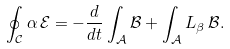Convert formula to latex. <formula><loc_0><loc_0><loc_500><loc_500>\oint _ { \mathcal { C } } \alpha \, \mathcal { E } = - \frac { d } { d t } \int _ { \mathcal { A } } \mathcal { B } + \int _ { \mathcal { A } } L _ { \beta } \, \mathcal { B } .</formula> 